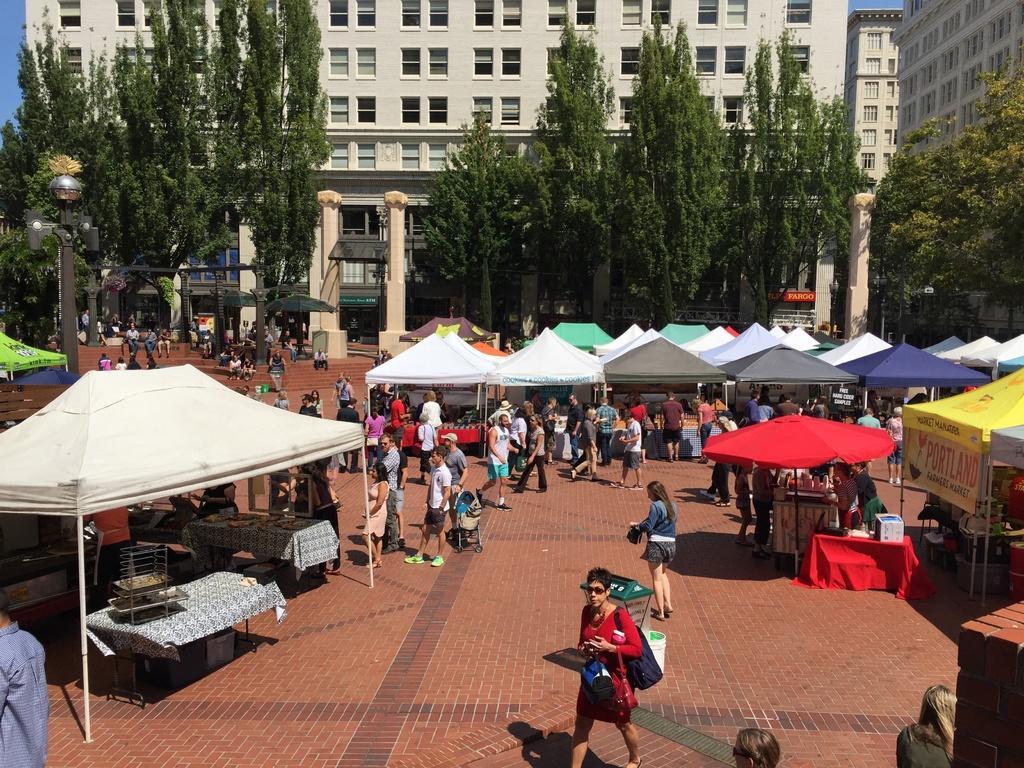Please provide a concise description of this image. In this image we can see there are so many stalls. In front of the stalls there are so many people standing. In the background there is a building, in front of the building there are trees. 